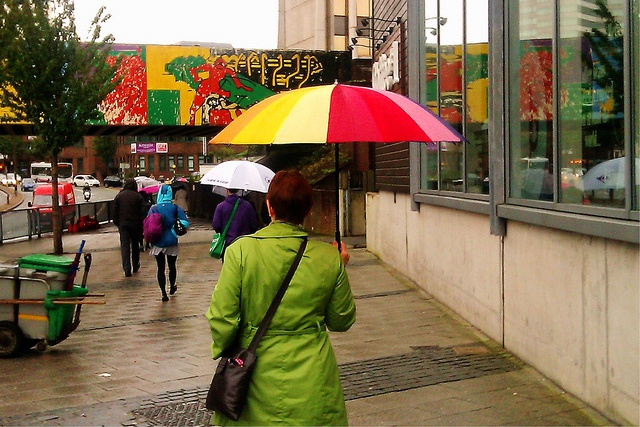Describe the objects in this image and their specific colors. I can see people in darkgreen, black, and olive tones, umbrella in darkgreen, red, khaki, gold, and lightpink tones, handbag in darkgreen, black, and maroon tones, people in darkgreen, black, gray, and maroon tones, and people in darkgreen, black, navy, and blue tones in this image. 